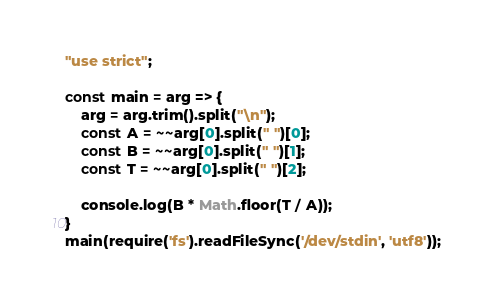<code> <loc_0><loc_0><loc_500><loc_500><_JavaScript_>"use strict";
    
const main = arg => {
    arg = arg.trim().split("\n");
    const A = ~~arg[0].split(" ")[0];
    const B = ~~arg[0].split(" ")[1];
    const T = ~~arg[0].split(" ")[2];
    
    console.log(B * Math.floor(T / A));
}
main(require('fs').readFileSync('/dev/stdin', 'utf8'));</code> 